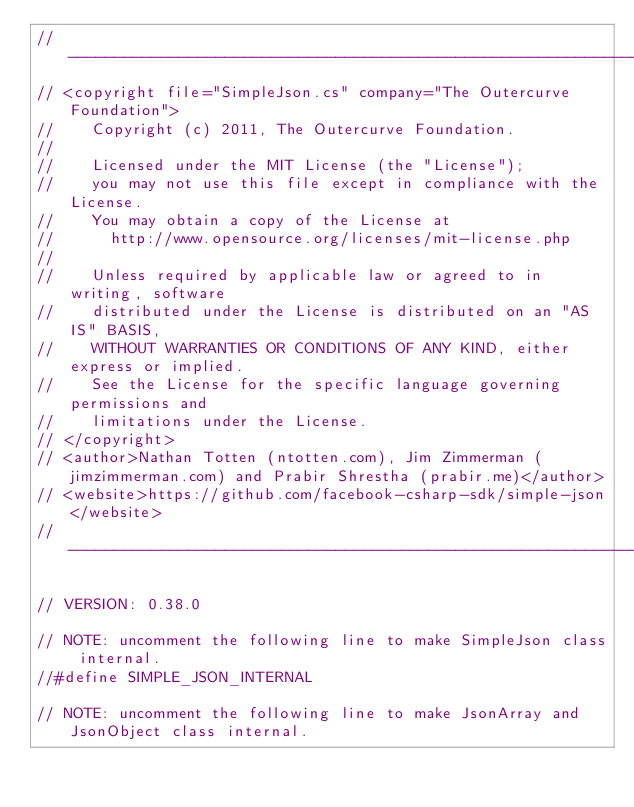Convert code to text. <code><loc_0><loc_0><loc_500><loc_500><_C#_>//-----------------------------------------------------------------------
// <copyright file="SimpleJson.cs" company="The Outercurve Foundation">
//    Copyright (c) 2011, The Outercurve Foundation.
//
//    Licensed under the MIT License (the "License");
//    you may not use this file except in compliance with the License.
//    You may obtain a copy of the License at
//      http://www.opensource.org/licenses/mit-license.php
//
//    Unless required by applicable law or agreed to in writing, software
//    distributed under the License is distributed on an "AS IS" BASIS,
//    WITHOUT WARRANTIES OR CONDITIONS OF ANY KIND, either express or implied.
//    See the License for the specific language governing permissions and
//    limitations under the License.
// </copyright>
// <author>Nathan Totten (ntotten.com), Jim Zimmerman (jimzimmerman.com) and Prabir Shrestha (prabir.me)</author>
// <website>https://github.com/facebook-csharp-sdk/simple-json</website>
//-----------------------------------------------------------------------

// VERSION: 0.38.0

// NOTE: uncomment the following line to make SimpleJson class internal.
//#define SIMPLE_JSON_INTERNAL

// NOTE: uncomment the following line to make JsonArray and JsonObject class internal.</code> 